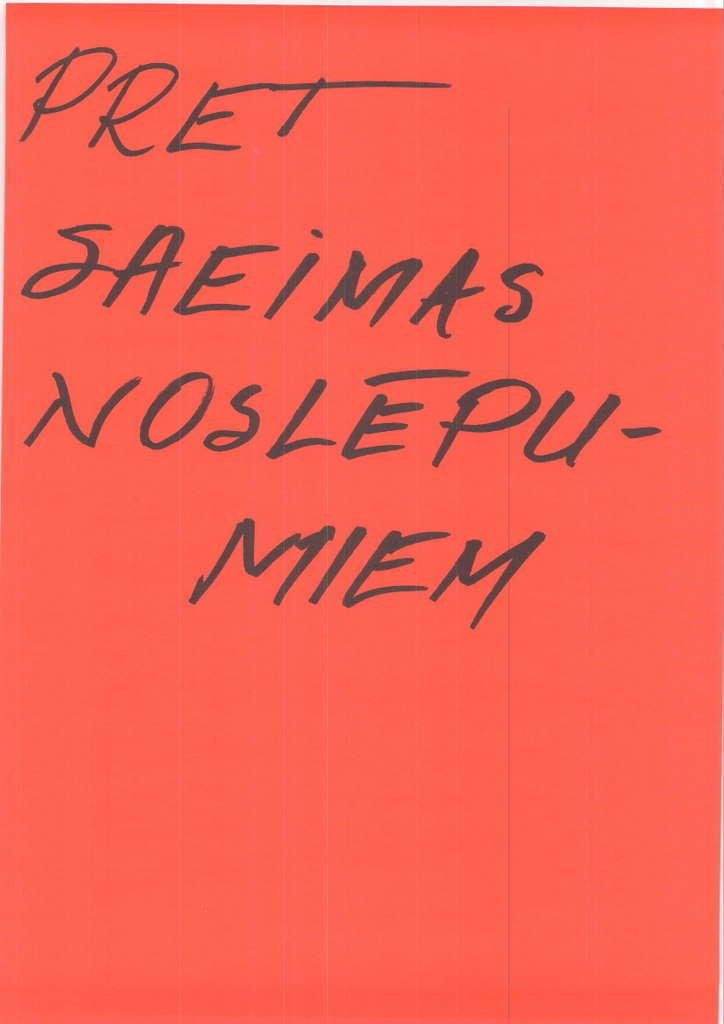<image>
Create a compact narrative representing the image presented. A red background displaying "PRET SAMEIMAS NOSLEPU - MEIM" 